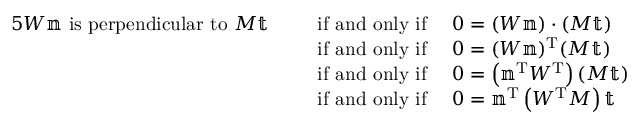Convert formula to latex. <formula><loc_0><loc_0><loc_500><loc_500>{ \begin{array} { r l } { { 5 } W \mathbb { n } { i s p e r p e n d i c u l a r t o } M \mathbb { t } \quad \, } & { { i f a n d o n l y i f } \quad 0 = ( W \mathbb { n } ) \cdot ( M \mathbb { t } ) } \\ & { { i f a n d o n l y i f } \quad 0 = ( W \mathbb { n } ) ^ { T } ( M \mathbb { t } ) } \\ & { { i f a n d o n l y i f } \quad 0 = \left ( \mathbb { n } ^ { T } W ^ { T } \right ) ( M \mathbb { t } ) } \\ & { { i f a n d o n l y i f } \quad 0 = \mathbb { n } ^ { T } \left ( W ^ { T } M \right ) \mathbb { t } } \end{array} }</formula> 